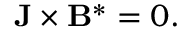<formula> <loc_0><loc_0><loc_500><loc_500>\begin{array} { r } { { J } \times { B } ^ { * } = 0 . } \end{array}</formula> 